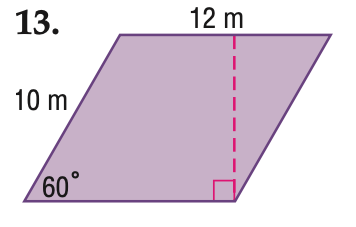Answer the mathemtical geometry problem and directly provide the correct option letter.
Question: Find the area of the parallelogram. Round to the nearest tenth if necessary.
Choices: A: 60 B: 84.9 C: 103.9 D: 120 C 